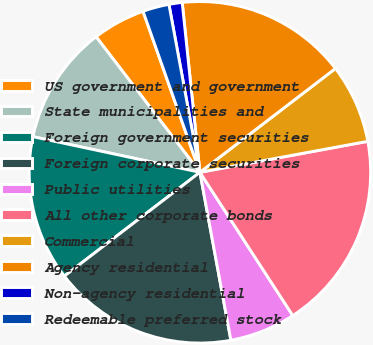<chart> <loc_0><loc_0><loc_500><loc_500><pie_chart><fcel>US government and government<fcel>State municipalities and<fcel>Foreign government securities<fcel>Foreign corporate securities<fcel>Public utilities<fcel>All other corporate bonds<fcel>Commercial<fcel>Agency residential<fcel>Non-agency residential<fcel>Redeemable preferred stock<nl><fcel>5.0%<fcel>11.25%<fcel>13.75%<fcel>17.5%<fcel>6.25%<fcel>18.75%<fcel>7.5%<fcel>16.25%<fcel>1.25%<fcel>2.5%<nl></chart> 